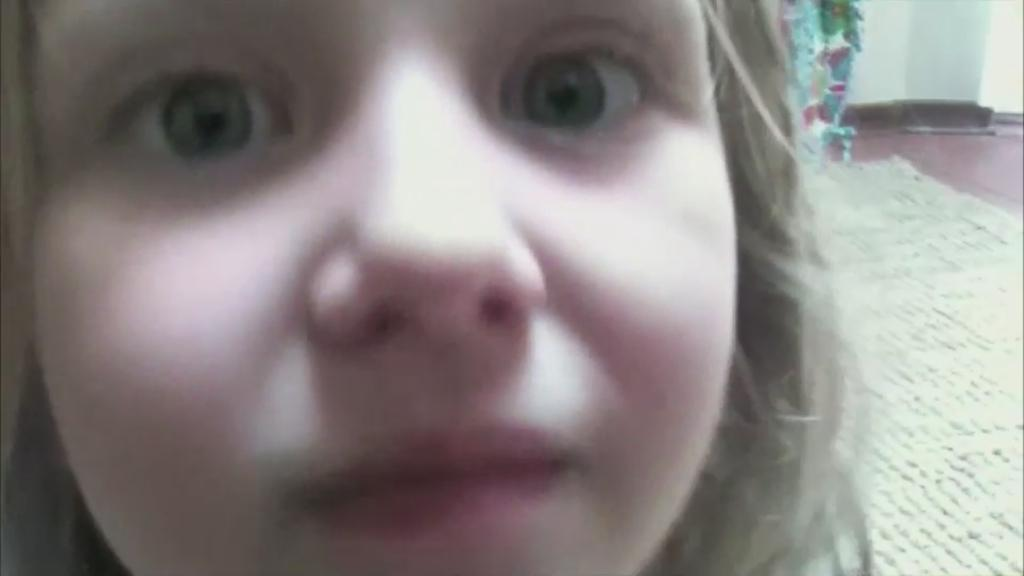What is the main subject of the image? There is a girl's face in the center of the image. What can be seen in the background of the image? There is a carpet and a wall in the background of the image. What type of celery is growing on the wall in the image? There is no celery present in the image; it features a girl's face and a wall in the background. How many spots can be seen on the girl's face in the image? There are no spots visible on the girl's face in the image. 